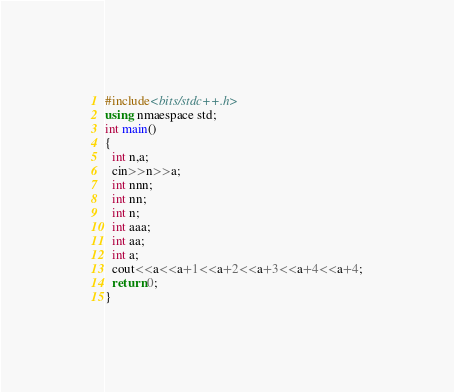<code> <loc_0><loc_0><loc_500><loc_500><_C++_>#include<bits/stdc++.h>
using nmaespace std;
int main()
{
  int n,a;
  cin>>n>>a;
  int nnn;
  int nn;
  int n;
  int aaa;
  int aa;
  int a;
  cout<<a<<a+1<<a+2<<a+3<<a+4<<a+4;
  return 0;
}</code> 